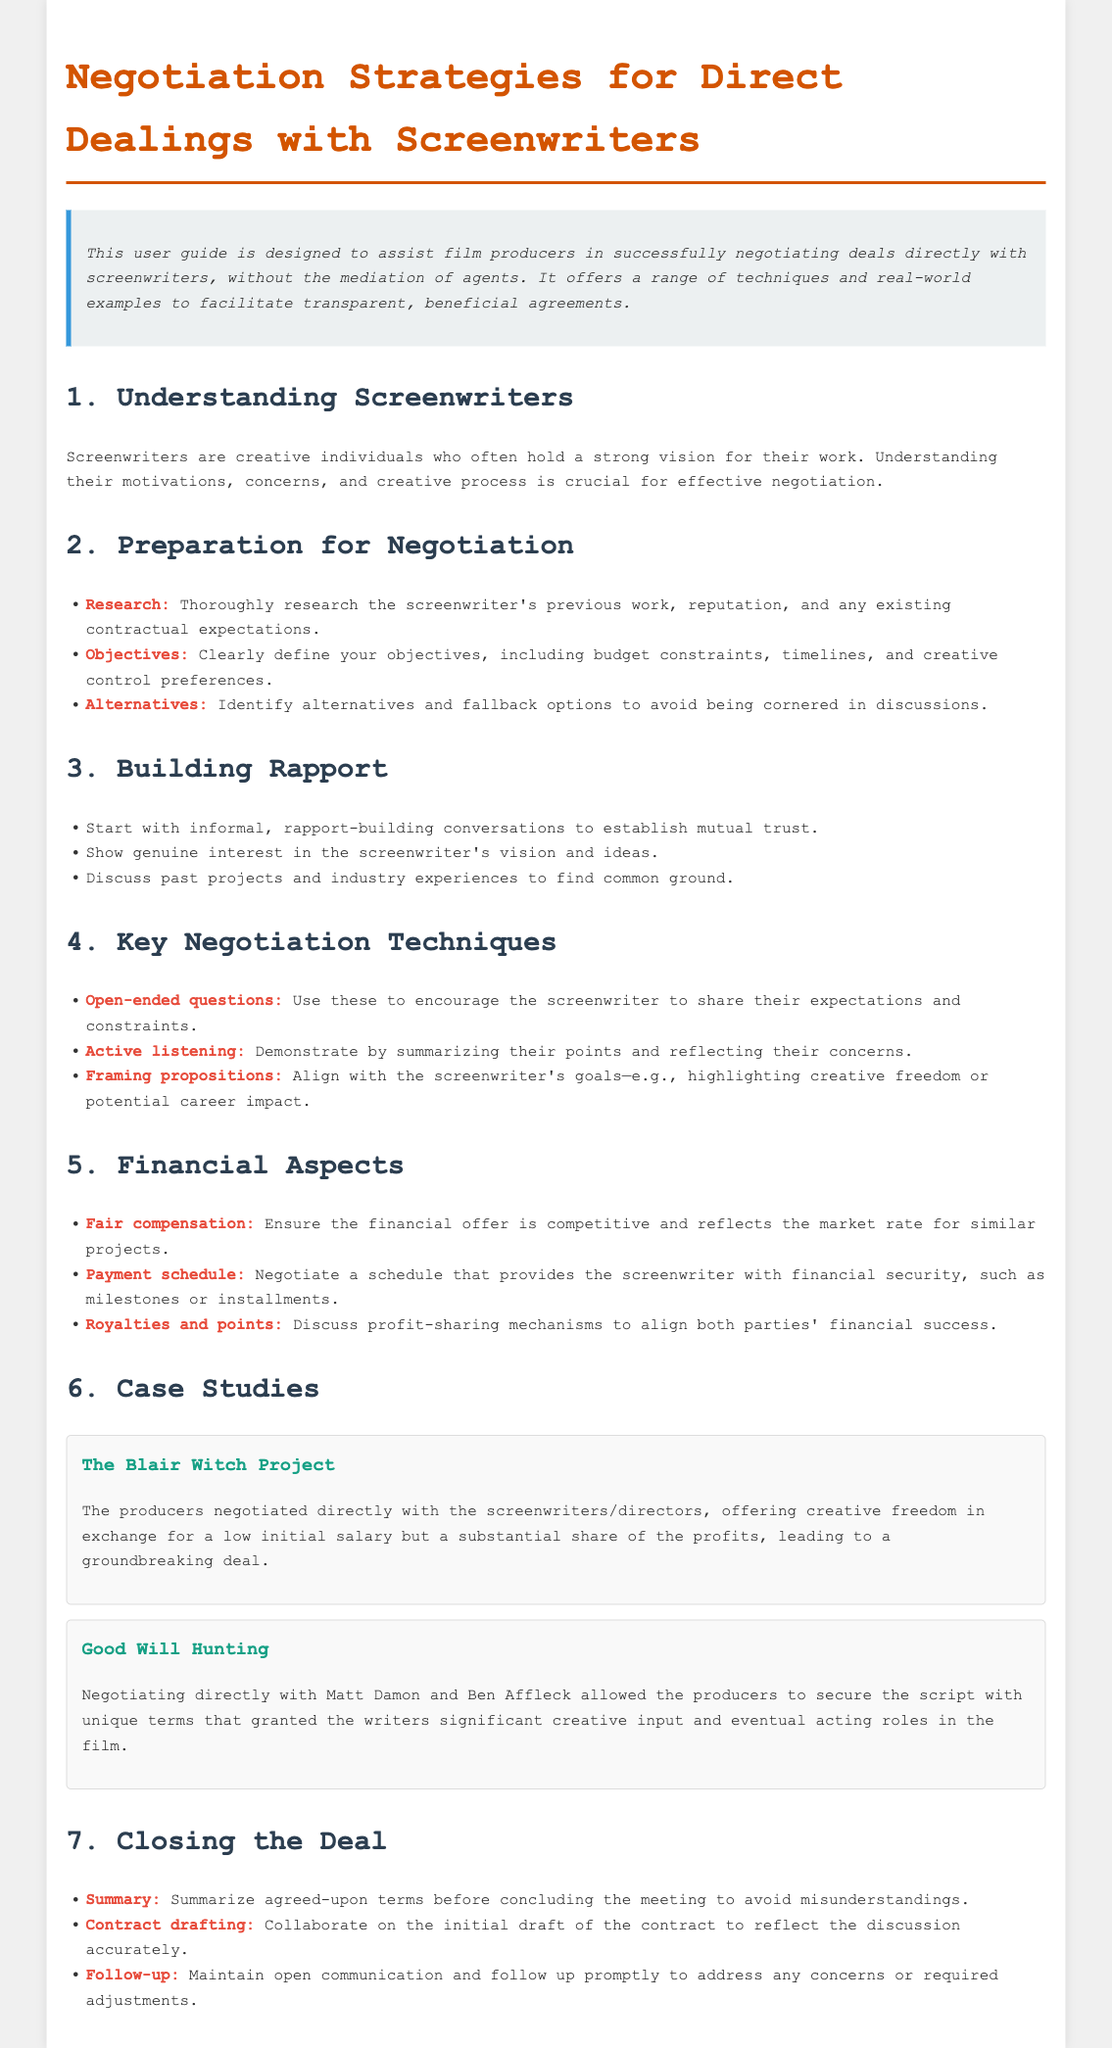What is the title of the document? The title of the document is clearly stated in the heading.
Answer: Negotiation Strategies for Direct Dealings with Screenwriters What is emphasized as a key point in the preparation for negotiation? The document lists important elements for preparation, highlighting significant aspects.
Answer: Research Which film case study involved a groundbreaking deal? The document specifies notable films that serve as examples of successful negotiation.
Answer: The Blair Witch Project What should be summarized before concluding a meeting? The document outlines necessary actions to take as the negotiation comes to an end.
Answer: Agreed-upon terms What is a recommended technique for building rapport? The document provides techniques for establishing relationships with screenwriters.
Answer: Informal conversations What aspect of financial negotiations is highlighted for ensuring security? The document discusses financial aspects that should be approached carefully during negotiations.
Answer: Payment schedule What is one of the objectives to define before negotiating? The document advises on setting clear goals prior to negotiations.
Answer: Budget constraints What communication method is suggested to show understanding of the screenwriter's points? The document emphasizes a technique to demonstrate effective listening during discussions.
Answer: Active listening 